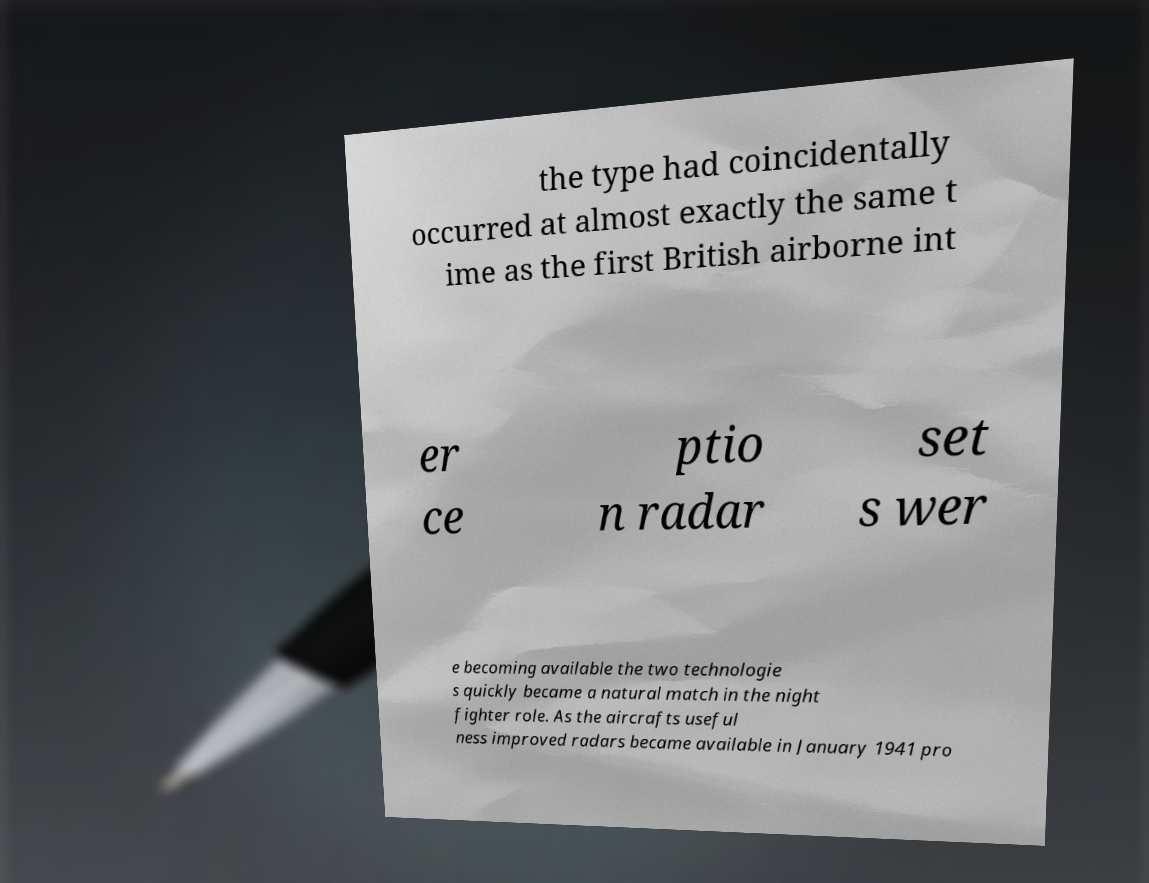Could you assist in decoding the text presented in this image and type it out clearly? the type had coincidentally occurred at almost exactly the same t ime as the first British airborne int er ce ptio n radar set s wer e becoming available the two technologie s quickly became a natural match in the night fighter role. As the aircrafts useful ness improved radars became available in January 1941 pro 